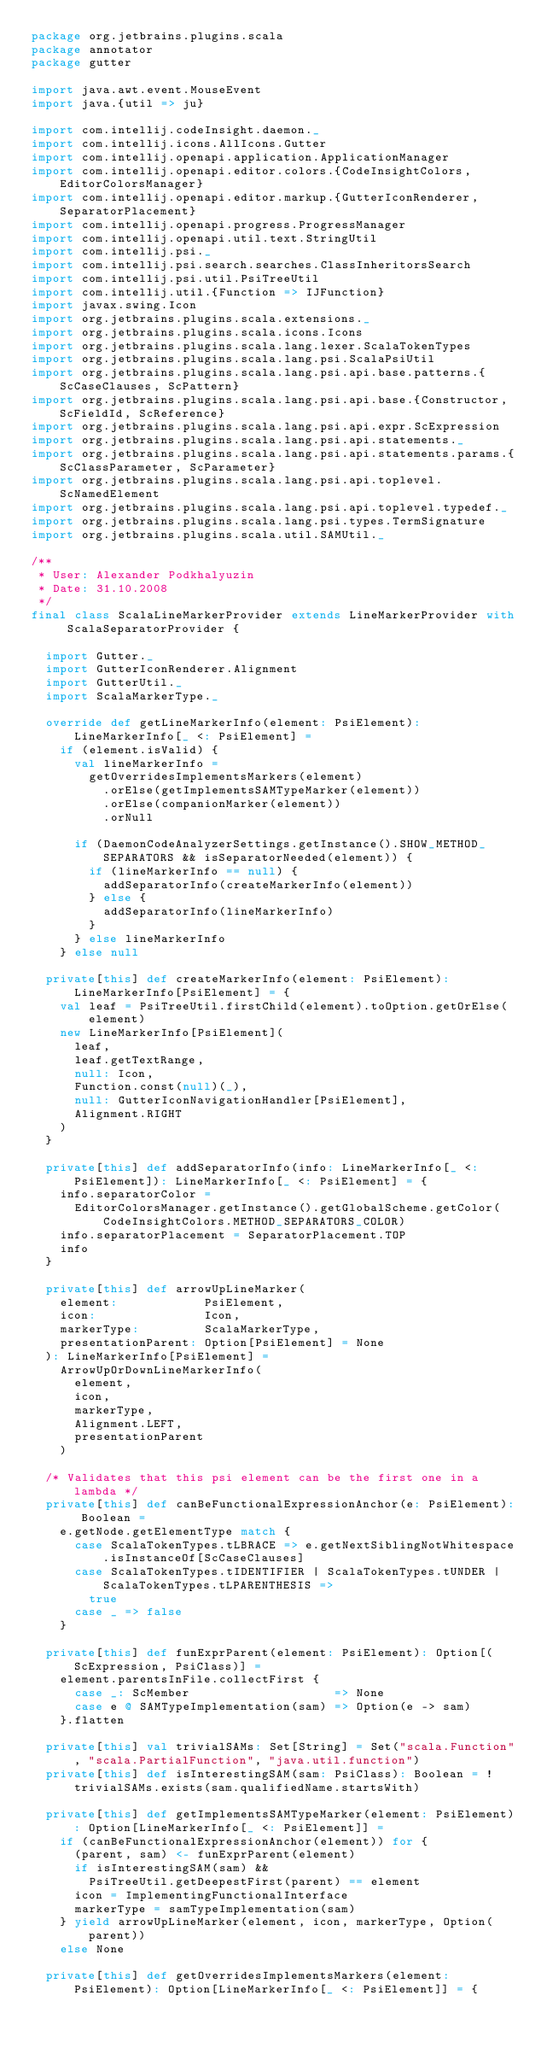<code> <loc_0><loc_0><loc_500><loc_500><_Scala_>package org.jetbrains.plugins.scala
package annotator
package gutter

import java.awt.event.MouseEvent
import java.{util => ju}

import com.intellij.codeInsight.daemon._
import com.intellij.icons.AllIcons.Gutter
import com.intellij.openapi.application.ApplicationManager
import com.intellij.openapi.editor.colors.{CodeInsightColors, EditorColorsManager}
import com.intellij.openapi.editor.markup.{GutterIconRenderer, SeparatorPlacement}
import com.intellij.openapi.progress.ProgressManager
import com.intellij.openapi.util.text.StringUtil
import com.intellij.psi._
import com.intellij.psi.search.searches.ClassInheritorsSearch
import com.intellij.psi.util.PsiTreeUtil
import com.intellij.util.{Function => IJFunction}
import javax.swing.Icon
import org.jetbrains.plugins.scala.extensions._
import org.jetbrains.plugins.scala.icons.Icons
import org.jetbrains.plugins.scala.lang.lexer.ScalaTokenTypes
import org.jetbrains.plugins.scala.lang.psi.ScalaPsiUtil
import org.jetbrains.plugins.scala.lang.psi.api.base.patterns.{ScCaseClauses, ScPattern}
import org.jetbrains.plugins.scala.lang.psi.api.base.{Constructor, ScFieldId, ScReference}
import org.jetbrains.plugins.scala.lang.psi.api.expr.ScExpression
import org.jetbrains.plugins.scala.lang.psi.api.statements._
import org.jetbrains.plugins.scala.lang.psi.api.statements.params.{ScClassParameter, ScParameter}
import org.jetbrains.plugins.scala.lang.psi.api.toplevel.ScNamedElement
import org.jetbrains.plugins.scala.lang.psi.api.toplevel.typedef._
import org.jetbrains.plugins.scala.lang.psi.types.TermSignature
import org.jetbrains.plugins.scala.util.SAMUtil._

/**
 * User: Alexander Podkhalyuzin
 * Date: 31.10.2008
 */
final class ScalaLineMarkerProvider extends LineMarkerProvider with ScalaSeparatorProvider {

  import Gutter._
  import GutterIconRenderer.Alignment
  import GutterUtil._
  import ScalaMarkerType._

  override def getLineMarkerInfo(element: PsiElement): LineMarkerInfo[_ <: PsiElement] =
    if (element.isValid) {
      val lineMarkerInfo =
        getOverridesImplementsMarkers(element)
          .orElse(getImplementsSAMTypeMarker(element))
          .orElse(companionMarker(element))
          .orNull

      if (DaemonCodeAnalyzerSettings.getInstance().SHOW_METHOD_SEPARATORS && isSeparatorNeeded(element)) {
        if (lineMarkerInfo == null) {
          addSeparatorInfo(createMarkerInfo(element))
        } else {
          addSeparatorInfo(lineMarkerInfo)
        }
      } else lineMarkerInfo
    } else null

  private[this] def createMarkerInfo(element: PsiElement): LineMarkerInfo[PsiElement] = {
    val leaf = PsiTreeUtil.firstChild(element).toOption.getOrElse(element)
    new LineMarkerInfo[PsiElement](
      leaf,
      leaf.getTextRange,
      null: Icon,
      Function.const(null)(_),
      null: GutterIconNavigationHandler[PsiElement],
      Alignment.RIGHT
    )
  }

  private[this] def addSeparatorInfo(info: LineMarkerInfo[_ <: PsiElement]): LineMarkerInfo[_ <: PsiElement] = {
    info.separatorColor =
      EditorColorsManager.getInstance().getGlobalScheme.getColor(CodeInsightColors.METHOD_SEPARATORS_COLOR)
    info.separatorPlacement = SeparatorPlacement.TOP
    info
  }

  private[this] def arrowUpLineMarker(
    element:            PsiElement,
    icon:               Icon,
    markerType:         ScalaMarkerType,
    presentationParent: Option[PsiElement] = None
  ): LineMarkerInfo[PsiElement] =
    ArrowUpOrDownLineMarkerInfo(
      element,
      icon,
      markerType,
      Alignment.LEFT,
      presentationParent
    )

  /* Validates that this psi element can be the first one in a lambda */
  private[this] def canBeFunctionalExpressionAnchor(e: PsiElement): Boolean =
    e.getNode.getElementType match {
      case ScalaTokenTypes.tLBRACE => e.getNextSiblingNotWhitespace.isInstanceOf[ScCaseClauses]
      case ScalaTokenTypes.tIDENTIFIER | ScalaTokenTypes.tUNDER | ScalaTokenTypes.tLPARENTHESIS =>
        true
      case _ => false
    }

  private[this] def funExprParent(element: PsiElement): Option[(ScExpression, PsiClass)] =
    element.parentsInFile.collectFirst {
      case _: ScMember                    => None
      case e @ SAMTypeImplementation(sam) => Option(e -> sam)
    }.flatten

  private[this] val trivialSAMs: Set[String] = Set("scala.Function", "scala.PartialFunction", "java.util.function")
  private[this] def isInterestingSAM(sam: PsiClass): Boolean = !trivialSAMs.exists(sam.qualifiedName.startsWith)

  private[this] def getImplementsSAMTypeMarker(element: PsiElement): Option[LineMarkerInfo[_ <: PsiElement]] =
    if (canBeFunctionalExpressionAnchor(element)) for {
      (parent, sam) <- funExprParent(element)
      if isInterestingSAM(sam) &&
        PsiTreeUtil.getDeepestFirst(parent) == element
      icon = ImplementingFunctionalInterface
      markerType = samTypeImplementation(sam)
    } yield arrowUpLineMarker(element, icon, markerType, Option(parent))
    else None

  private[this] def getOverridesImplementsMarkers(element: PsiElement): Option[LineMarkerInfo[_ <: PsiElement]] = {</code> 